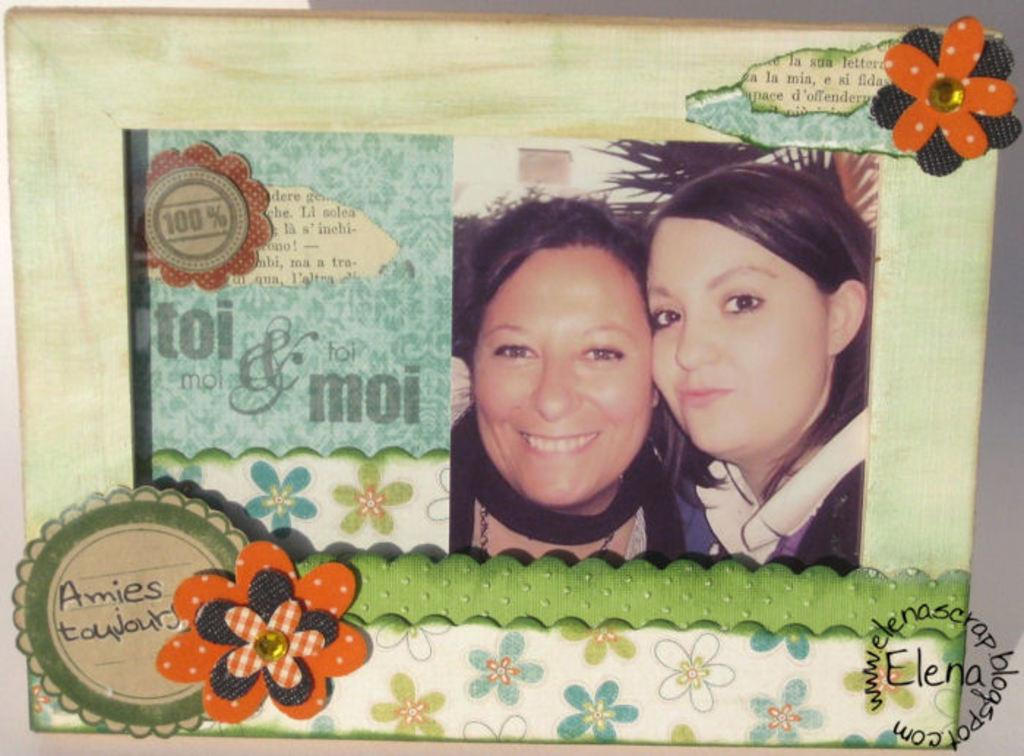What is present in the image that contains images and text? There is a poster in the image that contains images and text. What type of images are on the poster? The poster contains images of two women. What else can be seen on the poster besides the images? A symbol and a flower image are visible on the poster. Where is the kettle located in the image? There is no kettle present in the image. Are there any fairies visible on the poster? There are no fairies visible on the poster; it contains images of two women. 